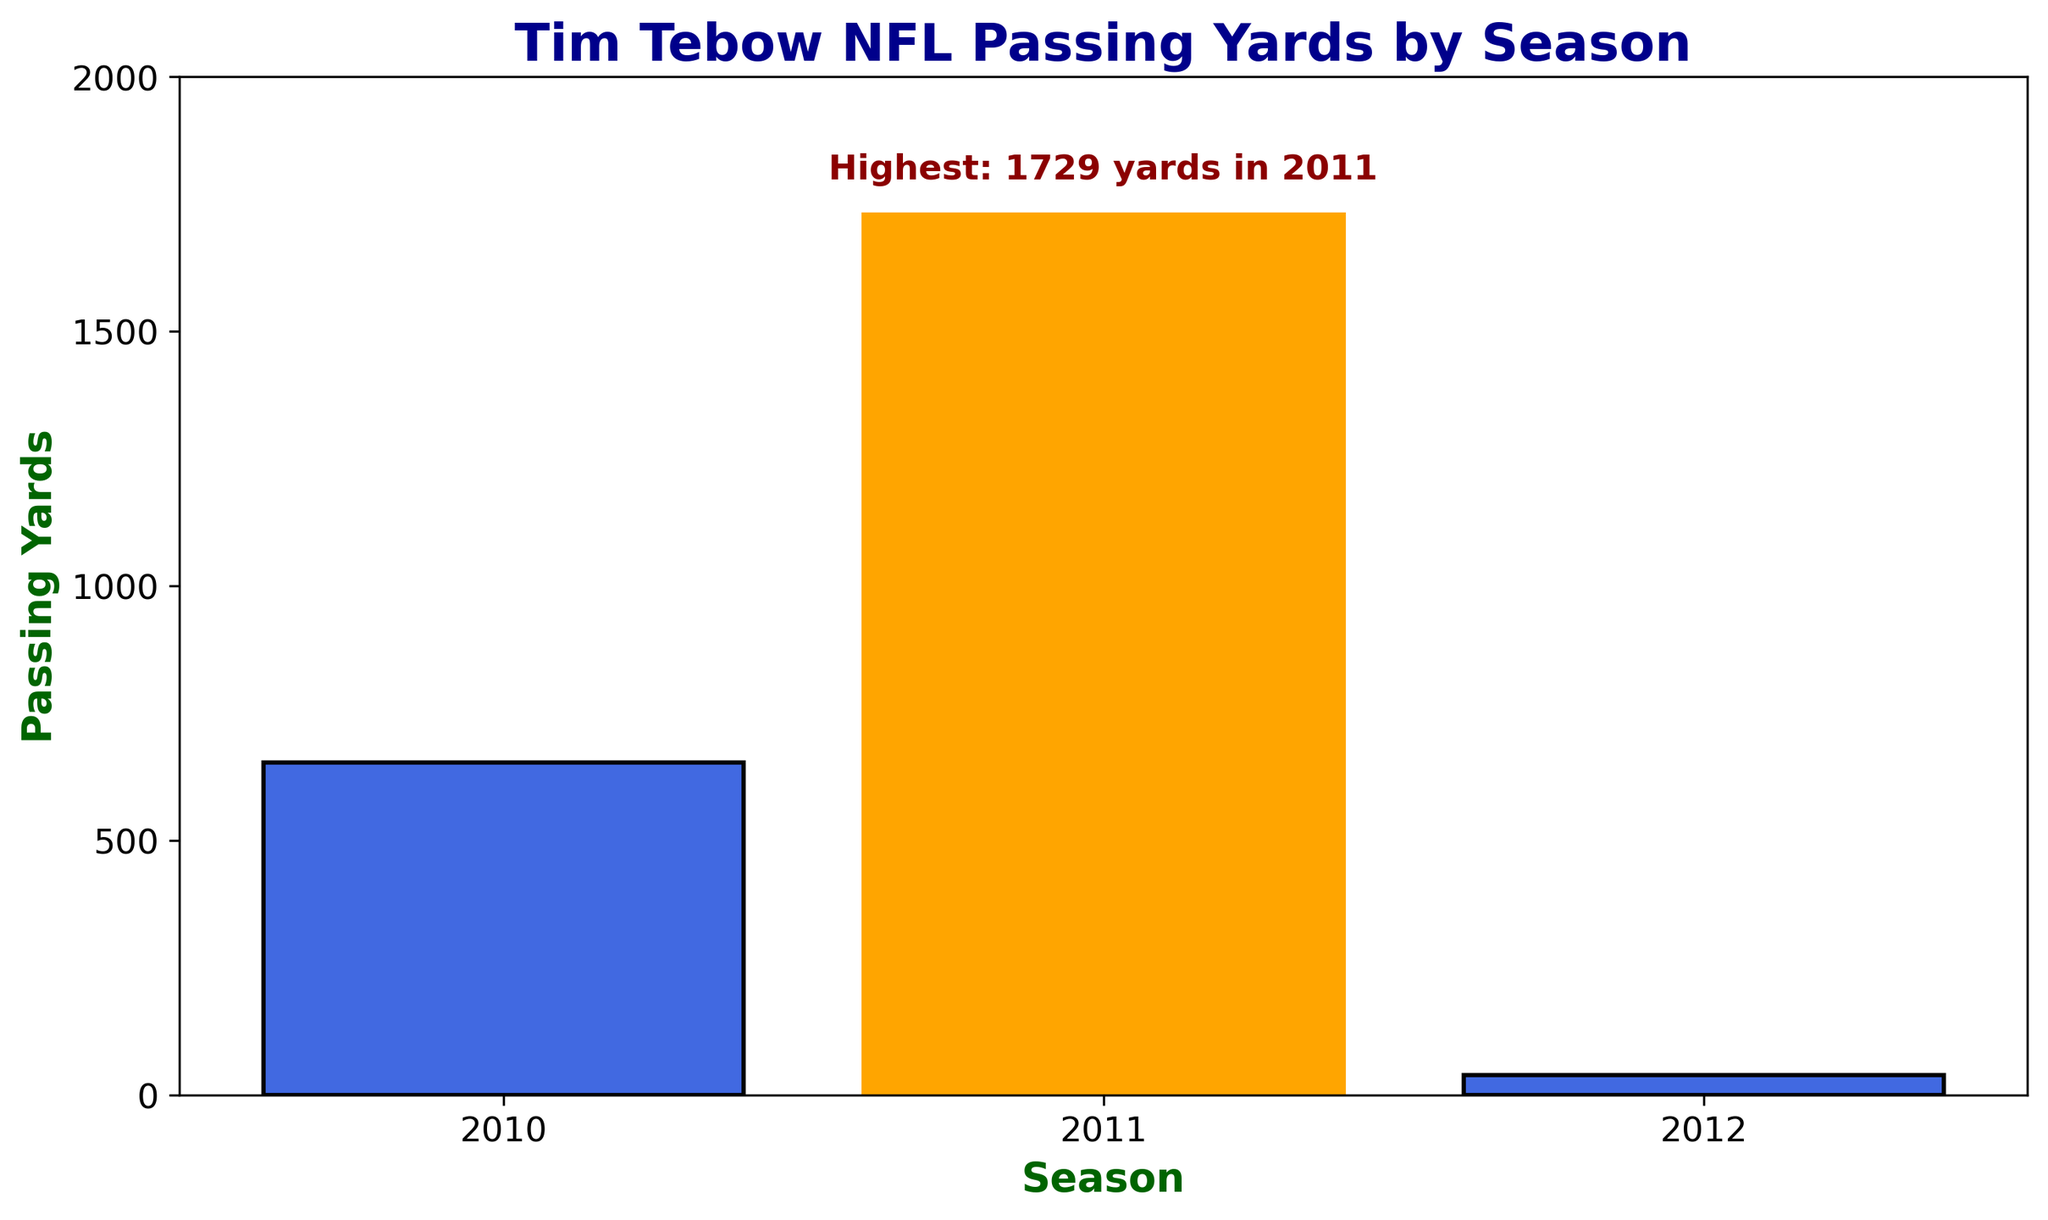Which season had Tim Tebow's highest passing yards? The bar that represents the highest passing yard season is highlighted in orange in the chart. The annotation near this bar indicates "Highest: 1729 yards in 2011". Therefore, 2011 is the season with the highest passing yards.
Answer: 2011 What was the total number of passing yards Tim Tebow achieved across all seasons in the NFL? To find the total passing yards, sum the passing yards from all seasons: 654 (2010) + 1729 (2011) + 39 (2012) = 2422 passing yards.
Answer: 2422 Comparing the 2010 and 2011 seasons, how many more passing yards did Tim Tebow achieve in 2011? Subtract the passing yards in 2010 from the passing yards in 2011: 1729 (2011) - 654 (2010) = 1075 more passing yards in 2011.
Answer: 1075 Which team did Tim Tebow play for in 2012 and how many passing yards did he achieve that season? The chart shows that in 2012, Tim Tebow played for the New York Jets and achieved 39 passing yards, as indicated by the bar labeled "2012, New York Jets".
Answer: New York Jets, 39 What is the average number of passing yards per season for Tim Tebow in the NFL? To find the average passing yards per season, sum the passing yards and divide by the number of seasons: (654 + 1729 + 39) / 3 = 2422 / 3 ≈ 807.33 yards per season.
Answer: 807.33 Is there any season where Tim Tebow had fewer than 100 passing yards? If so, which season? The chart shows a bar for the 2012 season that represents 39 passing yards, which is fewer than 100 passing yards.
Answer: 2012 If you look at the colors of the bars, what visual feature is unique about the season with the highest passing yards? The bar representing the highest passing yards (in 2011) is highlighted in orange, whereas the other bars are in royal blue.
Answer: Orange color for 2011 How does the height of the bar for his 2011 passing yards compare to his 2010 passing yards? The height of the bar for 2011 is significantly taller than the bar for 2010. This visually indicates that 2011 passing yards were much higher than those in 2010.
Answer: Much taller What is the difference in passing yards between the Denver Broncos and New York Jets seasons for Tim Tebow? For the Denver Broncos: 654 (2010) + 1729 (2011) = 2383 yards. For the New York Jets: 39 (2012) yards. The difference is 2383 - 39 = 2344 yards.
Answer: 2344 